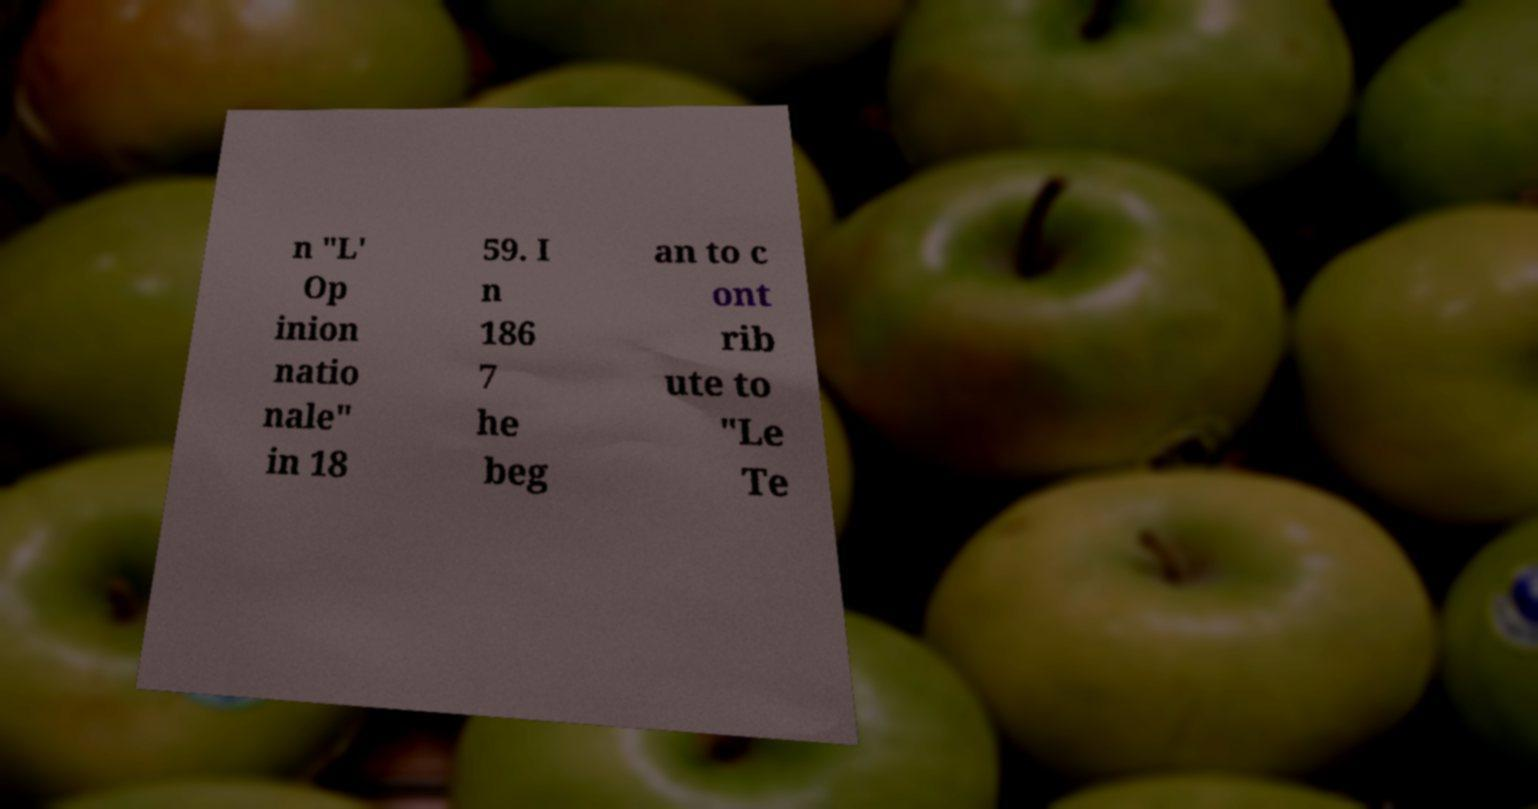Could you assist in decoding the text presented in this image and type it out clearly? n "L' Op inion natio nale" in 18 59. I n 186 7 he beg an to c ont rib ute to "Le Te 